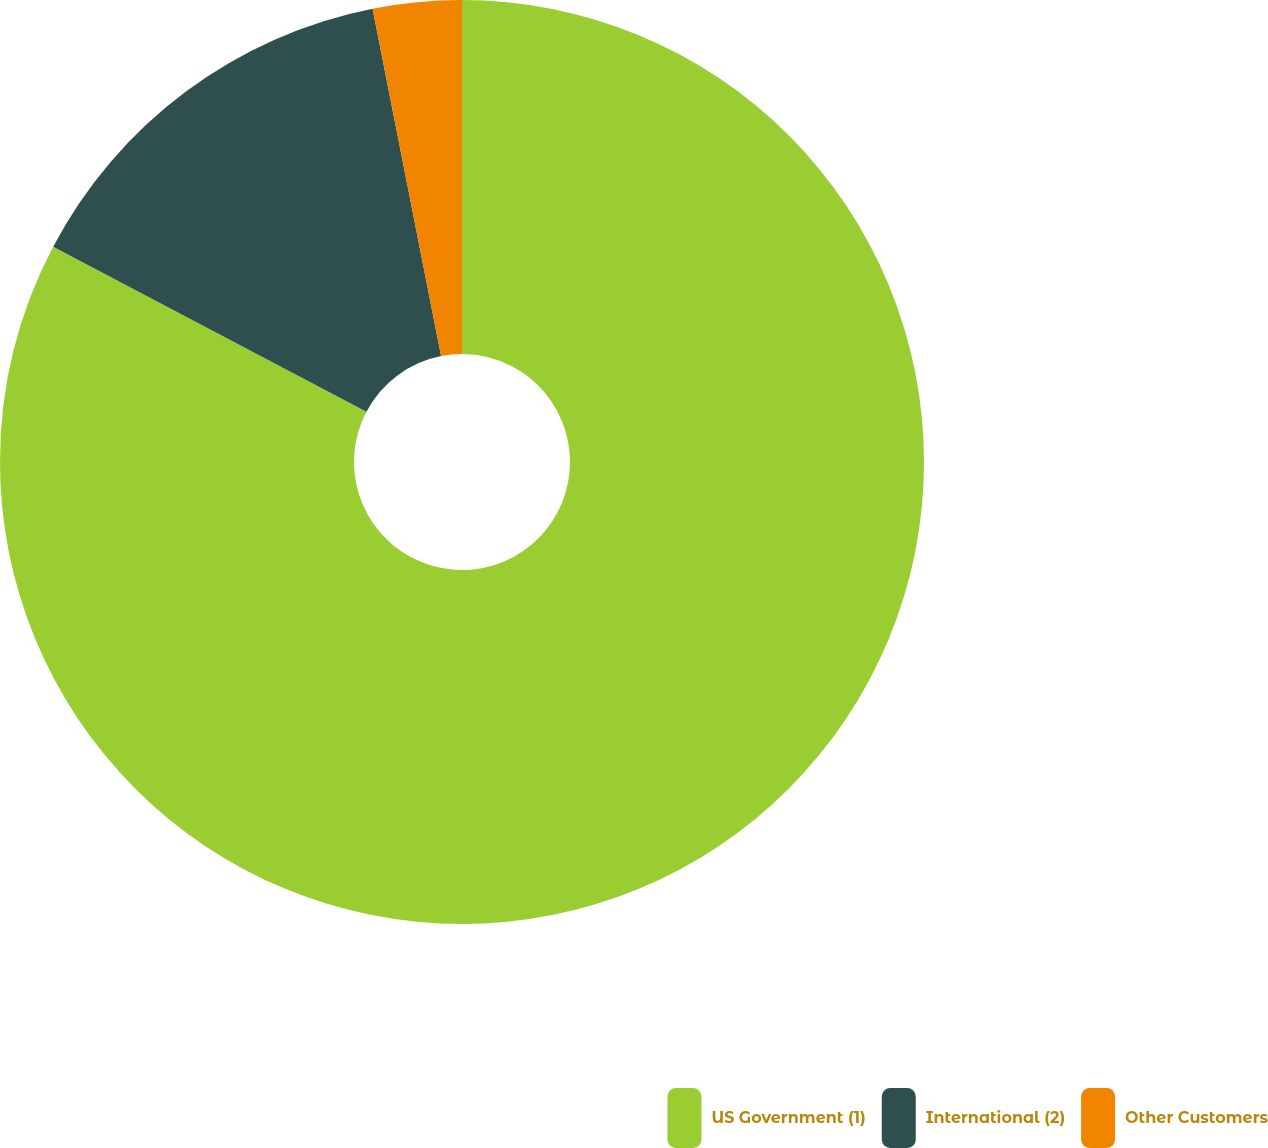Convert chart to OTSL. <chart><loc_0><loc_0><loc_500><loc_500><pie_chart><fcel>US Government (1)<fcel>International (2)<fcel>Other Customers<nl><fcel>82.71%<fcel>14.19%<fcel>3.1%<nl></chart> 